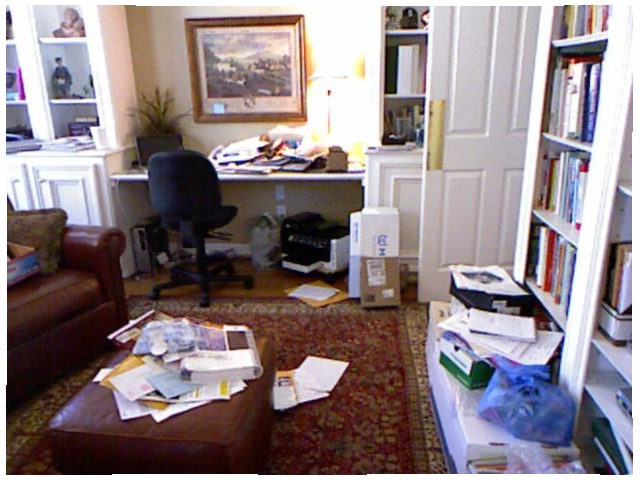<image>
Can you confirm if the photo is on the table? No. The photo is not positioned on the table. They may be near each other, but the photo is not supported by or resting on top of the table. Where is the picture in relation to the couch? Is it on the couch? No. The picture is not positioned on the couch. They may be near each other, but the picture is not supported by or resting on top of the couch. 